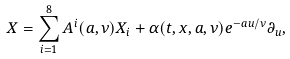Convert formula to latex. <formula><loc_0><loc_0><loc_500><loc_500>X = \sum _ { i = 1 } ^ { 8 } A ^ { i } ( a , \nu ) X _ { i } + \alpha ( t , x , a , \nu ) e ^ { - a u / \nu } \partial _ { u } ,</formula> 